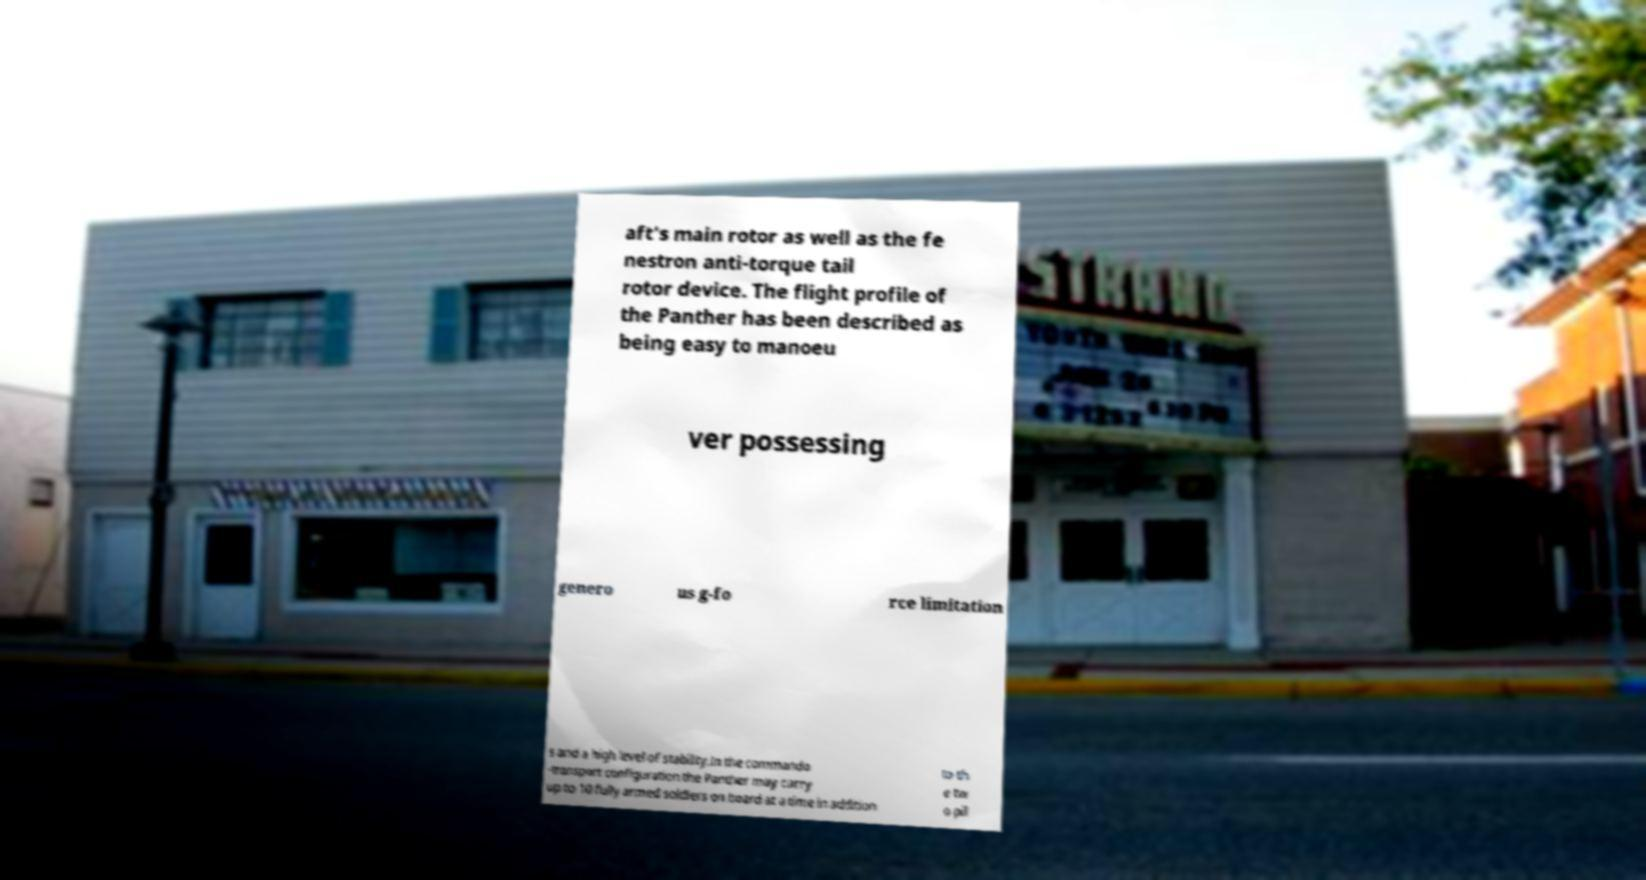Can you read and provide the text displayed in the image?This photo seems to have some interesting text. Can you extract and type it out for me? aft's main rotor as well as the fe nestron anti-torque tail rotor device. The flight profile of the Panther has been described as being easy to manoeu ver possessing genero us g-fo rce limitation s and a high level of stability.In the commando -transport configuration the Panther may carry up to 10 fully armed soldiers on board at a time in addition to th e tw o pil 